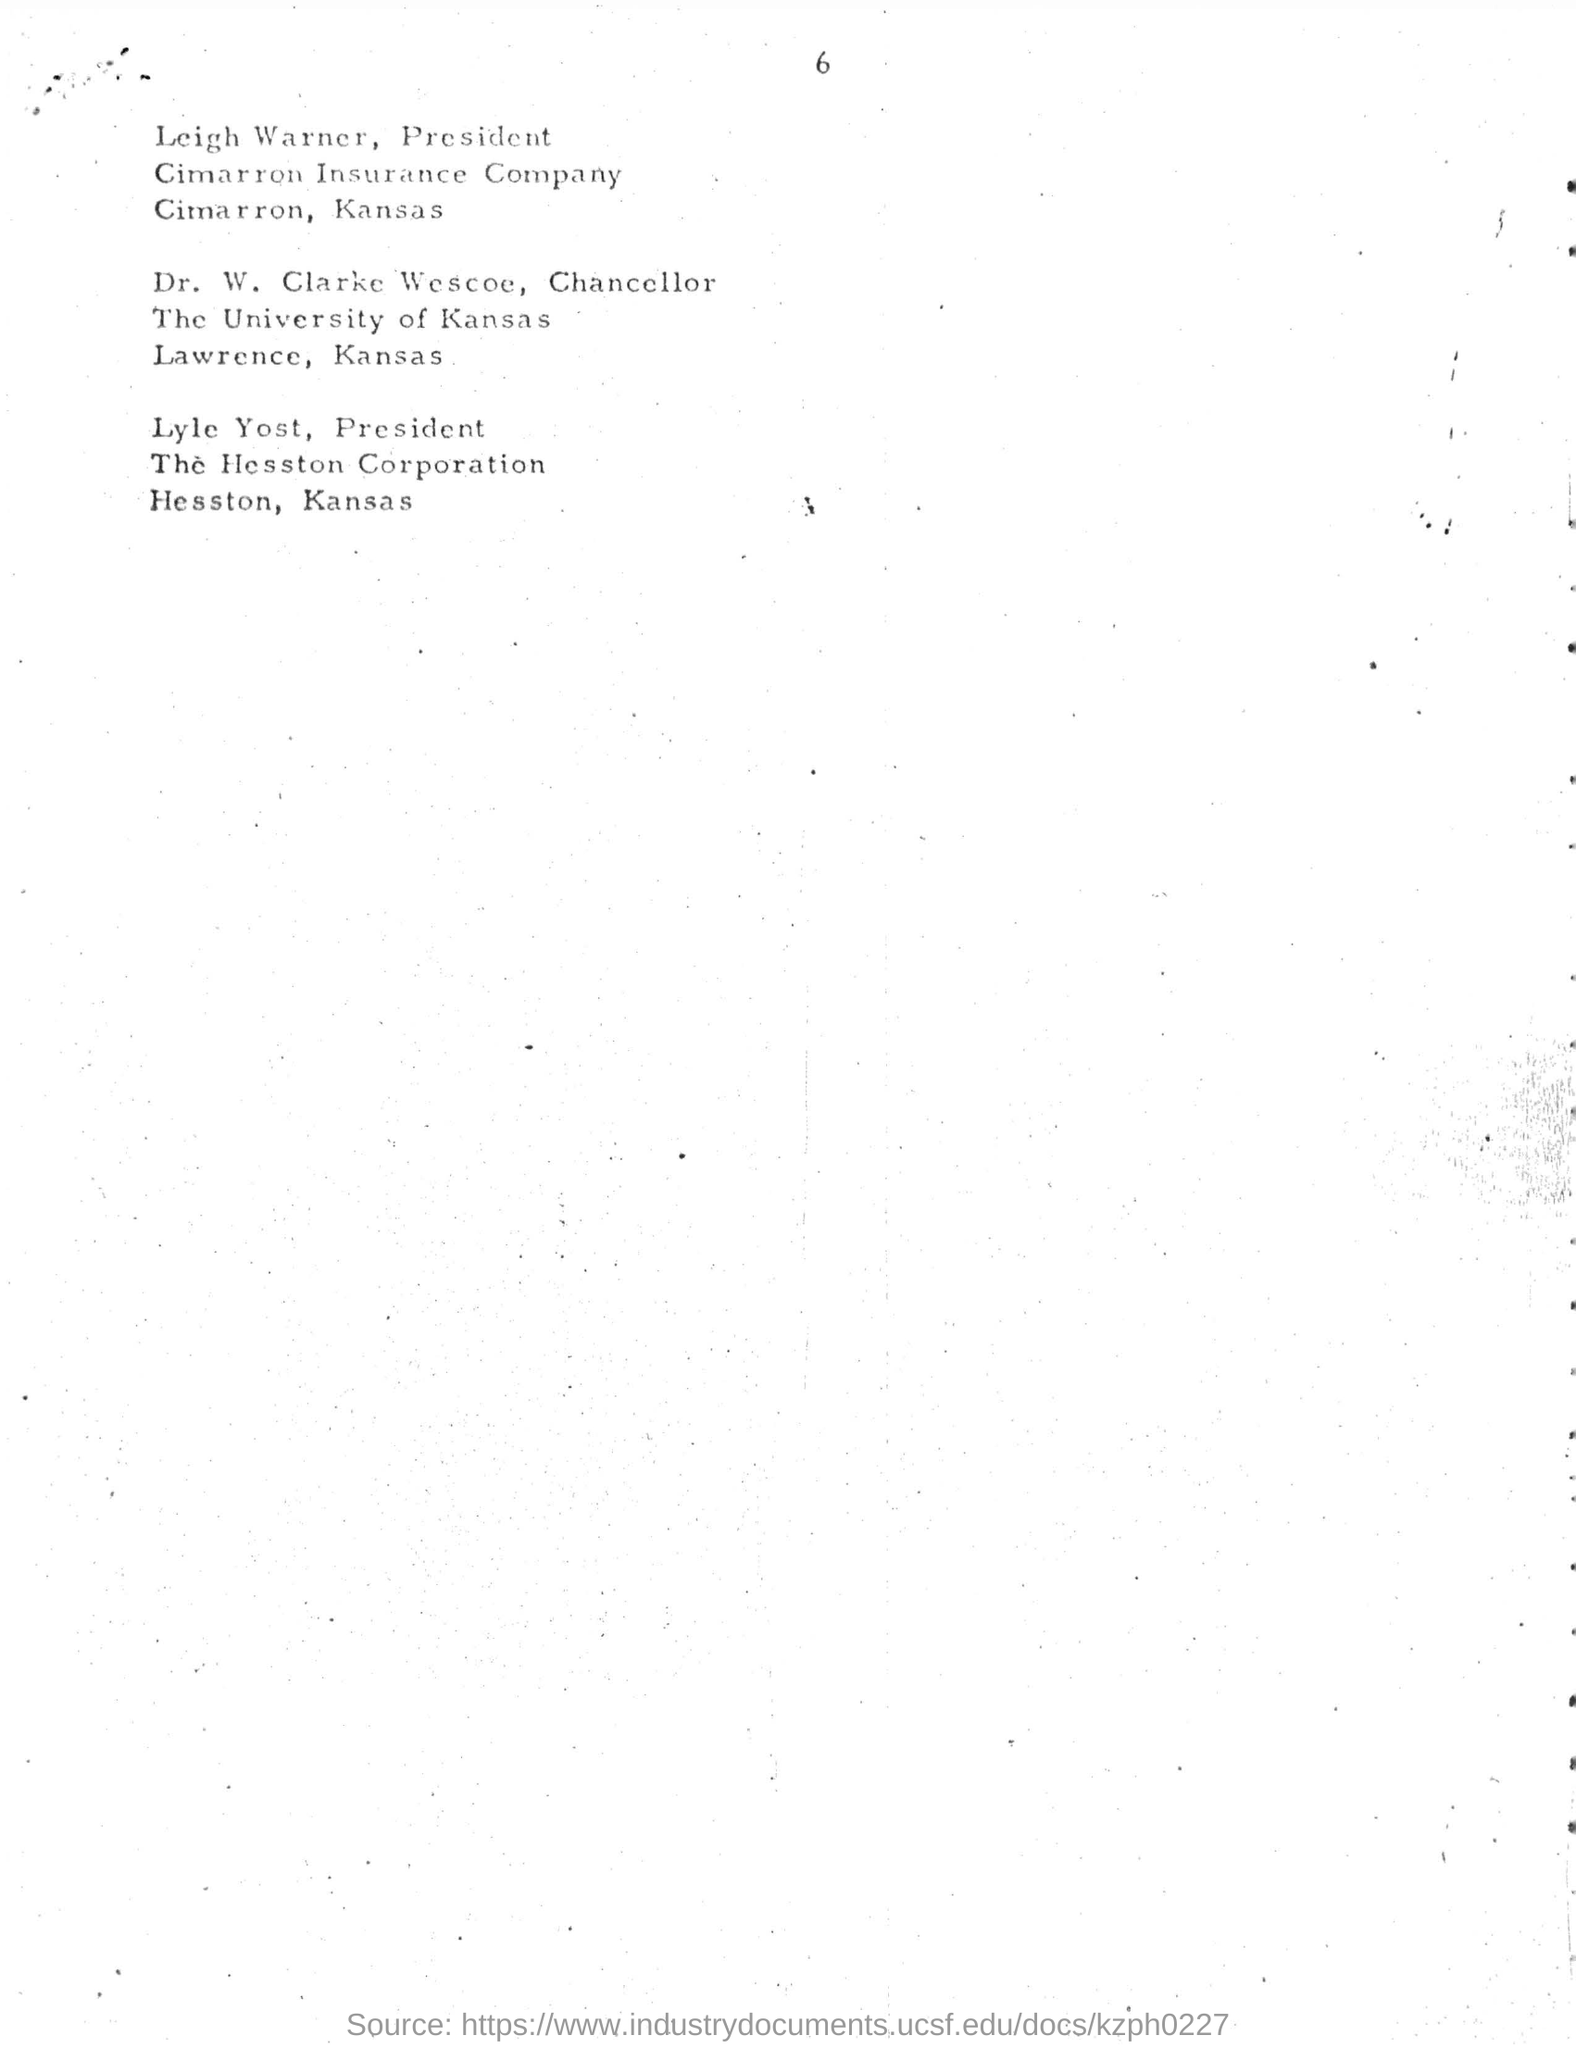List a handful of essential elements in this visual. Leigh Warner is the president of Cimarron Insurance Company. The location of Cimarron Insurance Company is Cimarron, Kansas. The University of Kansas is located in Lawrence, Kansas. Dr. W. Clarke Wescoe has been designated as the chancellor. Lyle Yost has been designated as the president of Hesston Corporation. 